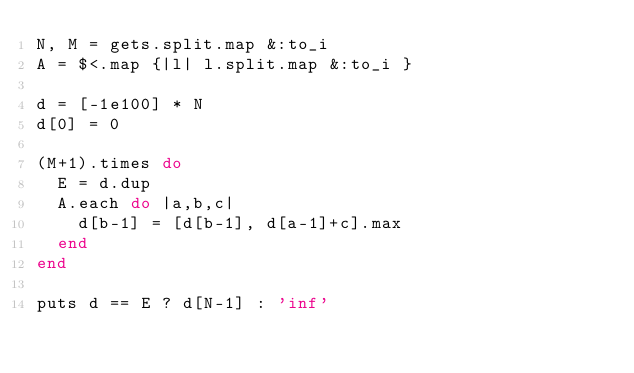Convert code to text. <code><loc_0><loc_0><loc_500><loc_500><_Ruby_>N, M = gets.split.map &:to_i
A = $<.map {|l| l.split.map &:to_i }

d = [-1e100] * N
d[0] = 0

(M+1).times do
  E = d.dup
  A.each do |a,b,c|
    d[b-1] = [d[b-1], d[a-1]+c].max
  end
end

puts d == E ? d[N-1] : 'inf'
</code> 